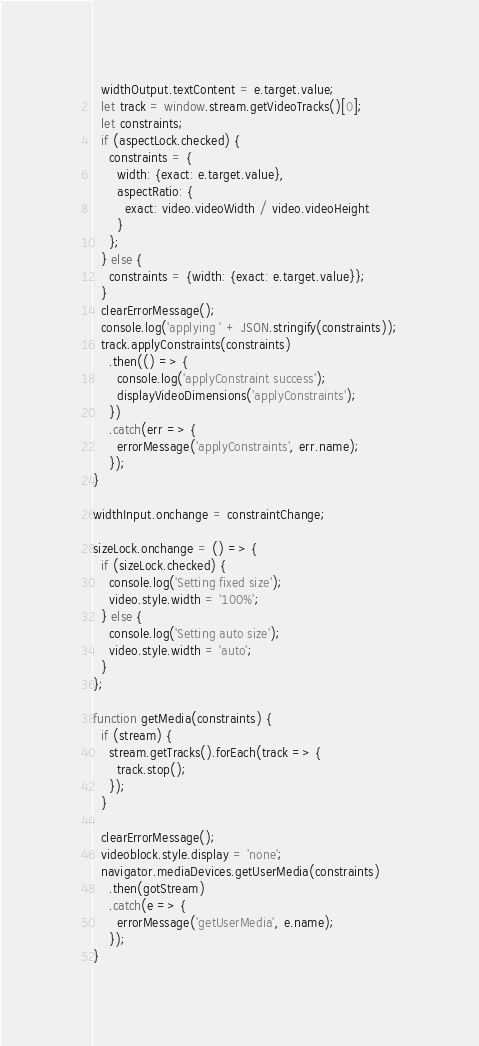Convert code to text. <code><loc_0><loc_0><loc_500><loc_500><_JavaScript_>  widthOutput.textContent = e.target.value;
  let track = window.stream.getVideoTracks()[0];
  let constraints;
  if (aspectLock.checked) {
    constraints = {
      width: {exact: e.target.value},
      aspectRatio: {
        exact: video.videoWidth / video.videoHeight
      }
    };
  } else {
    constraints = {width: {exact: e.target.value}};
  }
  clearErrorMessage();
  console.log('applying ' + JSON.stringify(constraints));
  track.applyConstraints(constraints)
    .then(() => {
      console.log('applyConstraint success');
      displayVideoDimensions('applyConstraints');
    })
    .catch(err => {
      errorMessage('applyConstraints', err.name);
    });
}

widthInput.onchange = constraintChange;

sizeLock.onchange = () => {
  if (sizeLock.checked) {
    console.log('Setting fixed size');
    video.style.width = '100%';
  } else {
    console.log('Setting auto size');
    video.style.width = 'auto';
  }
};

function getMedia(constraints) {
  if (stream) {
    stream.getTracks().forEach(track => {
      track.stop();
    });
  }

  clearErrorMessage();
  videoblock.style.display = 'none';
  navigator.mediaDevices.getUserMedia(constraints)
    .then(gotStream)
    .catch(e => {
      errorMessage('getUserMedia', e.name);
    });
}
</code> 